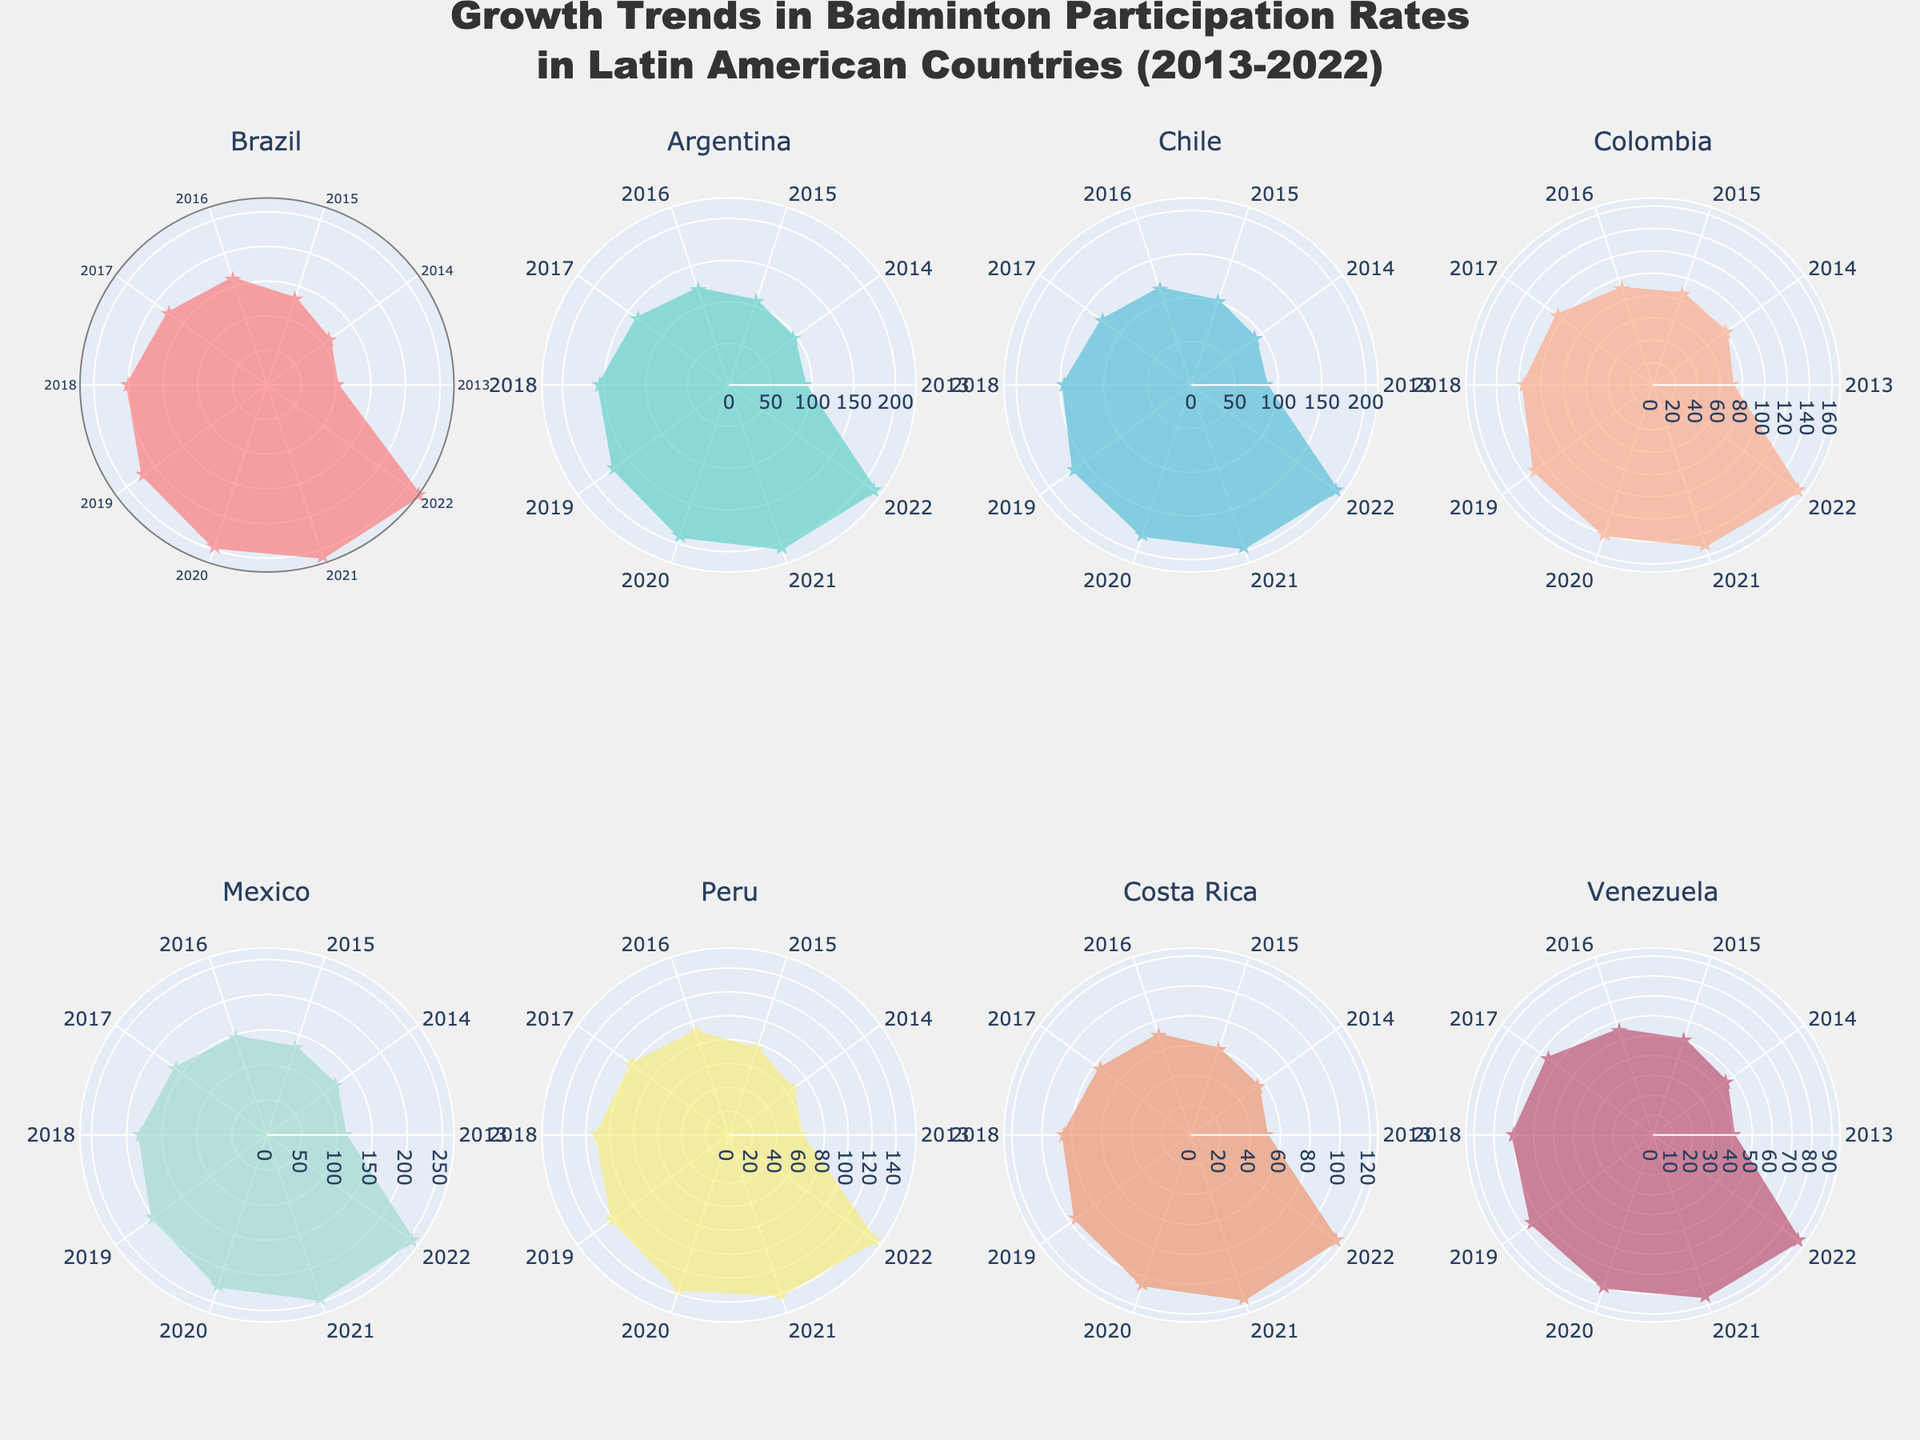Which country had the highest badminton participation rate in 2022? Look at the radar charts for each country and check the values for the year 2022. Brazil has the highest value at 270 participants.
Answer: Brazil What is the participation rate difference between Mexico and Peru in 2016? For 2016, Mexico's rate is 145 and Peru's rate is 90. The difference is 145 - 90 = 55.
Answer: 55 Which country shows the most consistent growth in participation over the years? Analyze the radar chart shapes for each country. Consistent growth is indicated by a smooth and steadily outward-pointing shape. Argentina shows a steady and consistent increase.
Answer: Argentina How did Colombia's badminton participation rate change from 2013 to 2022? Check Colombia's radar chart points for 2013 and 2022. The participation rate increased from 70 in 2013 to 160 in 2022, which is an increase of 90.
Answer: Increased by 90 Among the countries, which two have the closest participation rates in 2015? Compare the radar chart values for each country in 2015. Brazil has 130 participants and Mexico also has 130 participants.
Answer: Brazil and Mexico For Costa Rica, what's the percentage increase in participation from 2013 to 2022? Costa Rica's values are 50 in 2013 and 120 in 2022. The percentage increase is ((120-50)/50) * 100 = 140%.
Answer: 140% Which country had the lowest participation rate in 2018? Look for the lowest value in the 2018 data across all radar charts. Venezuela had the lowest with 70 participants.
Answer: Venezuela How does the growth trend of badminton in Venezuela compare with the other countries? Observe Venezuela's radar chart and compare the growth rate and shape with other countries. Venezuela shows the slowest and least consistent growth.
Answer: Slowest and least consistent growth What's the average participation rate for Chile in the last decade? Sum Chile's participation rates from 2013 to 2022 and divide by 10. (85+90+100+115+125+145+165+180+195+205)/10 = 140.5
Answer: 140.5 